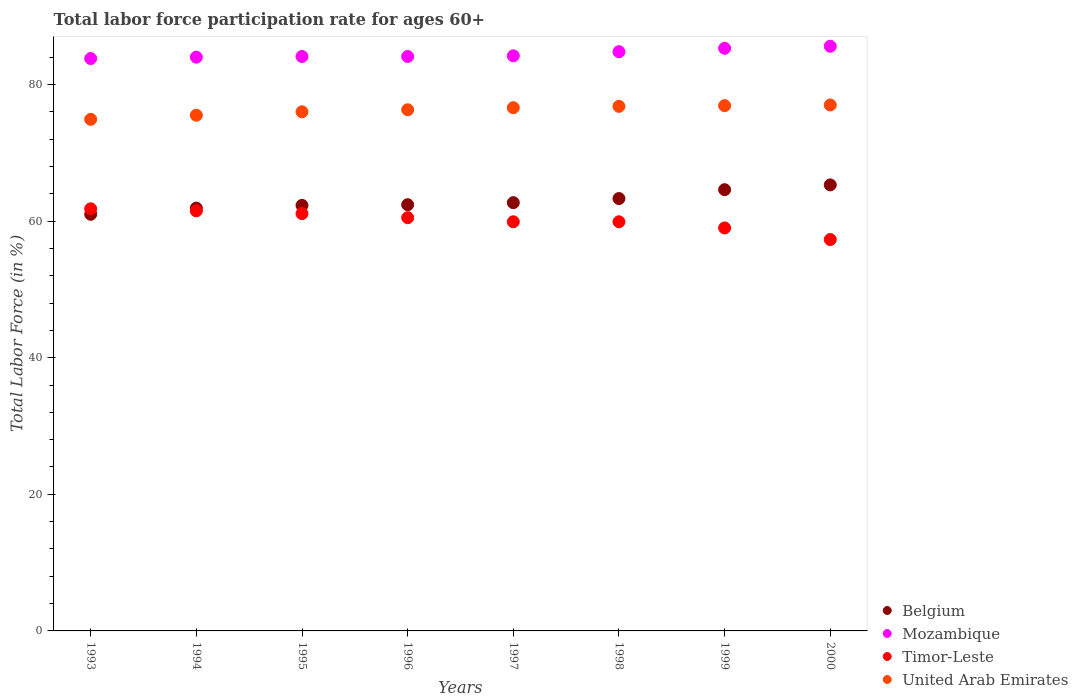Is the number of dotlines equal to the number of legend labels?
Ensure brevity in your answer.  Yes. What is the labor force participation rate in United Arab Emirates in 1996?
Make the answer very short. 76.3. Across all years, what is the maximum labor force participation rate in United Arab Emirates?
Provide a succinct answer. 77. Across all years, what is the minimum labor force participation rate in Mozambique?
Your answer should be very brief. 83.8. In which year was the labor force participation rate in Timor-Leste maximum?
Your response must be concise. 1993. In which year was the labor force participation rate in Mozambique minimum?
Keep it short and to the point. 1993. What is the total labor force participation rate in United Arab Emirates in the graph?
Provide a short and direct response. 610. What is the difference between the labor force participation rate in Timor-Leste in 1993 and that in 1994?
Ensure brevity in your answer.  0.3. What is the difference between the labor force participation rate in Belgium in 1998 and the labor force participation rate in Timor-Leste in 1996?
Offer a very short reply. 2.8. What is the average labor force participation rate in United Arab Emirates per year?
Offer a terse response. 76.25. In the year 2000, what is the difference between the labor force participation rate in Timor-Leste and labor force participation rate in United Arab Emirates?
Offer a terse response. -19.7. In how many years, is the labor force participation rate in Timor-Leste greater than 40 %?
Your response must be concise. 8. What is the ratio of the labor force participation rate in United Arab Emirates in 1993 to that in 1999?
Ensure brevity in your answer.  0.97. Is the labor force participation rate in Belgium in 1997 less than that in 1998?
Keep it short and to the point. Yes. What is the difference between the highest and the second highest labor force participation rate in Timor-Leste?
Keep it short and to the point. 0.3. What is the difference between the highest and the lowest labor force participation rate in Belgium?
Make the answer very short. 4.3. Is the sum of the labor force participation rate in Belgium in 1996 and 2000 greater than the maximum labor force participation rate in Timor-Leste across all years?
Offer a terse response. Yes. Is it the case that in every year, the sum of the labor force participation rate in Timor-Leste and labor force participation rate in Belgium  is greater than the sum of labor force participation rate in Mozambique and labor force participation rate in United Arab Emirates?
Give a very brief answer. No. Is it the case that in every year, the sum of the labor force participation rate in Mozambique and labor force participation rate in Belgium  is greater than the labor force participation rate in United Arab Emirates?
Make the answer very short. Yes. How many dotlines are there?
Your answer should be very brief. 4. How many years are there in the graph?
Provide a short and direct response. 8. Does the graph contain any zero values?
Keep it short and to the point. No. What is the title of the graph?
Make the answer very short. Total labor force participation rate for ages 60+. Does "World" appear as one of the legend labels in the graph?
Your answer should be very brief. No. What is the Total Labor Force (in %) in Belgium in 1993?
Offer a terse response. 61. What is the Total Labor Force (in %) of Mozambique in 1993?
Your answer should be very brief. 83.8. What is the Total Labor Force (in %) in Timor-Leste in 1993?
Provide a succinct answer. 61.8. What is the Total Labor Force (in %) of United Arab Emirates in 1993?
Your response must be concise. 74.9. What is the Total Labor Force (in %) in Belgium in 1994?
Provide a succinct answer. 61.9. What is the Total Labor Force (in %) of Mozambique in 1994?
Ensure brevity in your answer.  84. What is the Total Labor Force (in %) in Timor-Leste in 1994?
Provide a succinct answer. 61.5. What is the Total Labor Force (in %) in United Arab Emirates in 1994?
Your response must be concise. 75.5. What is the Total Labor Force (in %) in Belgium in 1995?
Make the answer very short. 62.3. What is the Total Labor Force (in %) of Mozambique in 1995?
Your answer should be very brief. 84.1. What is the Total Labor Force (in %) in Timor-Leste in 1995?
Your response must be concise. 61.1. What is the Total Labor Force (in %) of United Arab Emirates in 1995?
Your answer should be very brief. 76. What is the Total Labor Force (in %) of Belgium in 1996?
Provide a succinct answer. 62.4. What is the Total Labor Force (in %) in Mozambique in 1996?
Give a very brief answer. 84.1. What is the Total Labor Force (in %) in Timor-Leste in 1996?
Your answer should be compact. 60.5. What is the Total Labor Force (in %) in United Arab Emirates in 1996?
Keep it short and to the point. 76.3. What is the Total Labor Force (in %) of Belgium in 1997?
Give a very brief answer. 62.7. What is the Total Labor Force (in %) in Mozambique in 1997?
Offer a very short reply. 84.2. What is the Total Labor Force (in %) of Timor-Leste in 1997?
Provide a short and direct response. 59.9. What is the Total Labor Force (in %) in United Arab Emirates in 1997?
Keep it short and to the point. 76.6. What is the Total Labor Force (in %) of Belgium in 1998?
Keep it short and to the point. 63.3. What is the Total Labor Force (in %) of Mozambique in 1998?
Ensure brevity in your answer.  84.8. What is the Total Labor Force (in %) in Timor-Leste in 1998?
Offer a terse response. 59.9. What is the Total Labor Force (in %) in United Arab Emirates in 1998?
Ensure brevity in your answer.  76.8. What is the Total Labor Force (in %) of Belgium in 1999?
Provide a succinct answer. 64.6. What is the Total Labor Force (in %) of Mozambique in 1999?
Provide a succinct answer. 85.3. What is the Total Labor Force (in %) of United Arab Emirates in 1999?
Your answer should be compact. 76.9. What is the Total Labor Force (in %) in Belgium in 2000?
Your answer should be very brief. 65.3. What is the Total Labor Force (in %) of Mozambique in 2000?
Provide a short and direct response. 85.6. What is the Total Labor Force (in %) of Timor-Leste in 2000?
Ensure brevity in your answer.  57.3. Across all years, what is the maximum Total Labor Force (in %) of Belgium?
Provide a short and direct response. 65.3. Across all years, what is the maximum Total Labor Force (in %) in Mozambique?
Provide a succinct answer. 85.6. Across all years, what is the maximum Total Labor Force (in %) of Timor-Leste?
Provide a succinct answer. 61.8. Across all years, what is the maximum Total Labor Force (in %) of United Arab Emirates?
Provide a short and direct response. 77. Across all years, what is the minimum Total Labor Force (in %) of Mozambique?
Keep it short and to the point. 83.8. Across all years, what is the minimum Total Labor Force (in %) of Timor-Leste?
Your answer should be very brief. 57.3. Across all years, what is the minimum Total Labor Force (in %) in United Arab Emirates?
Give a very brief answer. 74.9. What is the total Total Labor Force (in %) of Belgium in the graph?
Your answer should be very brief. 503.5. What is the total Total Labor Force (in %) in Mozambique in the graph?
Make the answer very short. 675.9. What is the total Total Labor Force (in %) of Timor-Leste in the graph?
Offer a very short reply. 481. What is the total Total Labor Force (in %) in United Arab Emirates in the graph?
Ensure brevity in your answer.  610. What is the difference between the Total Labor Force (in %) of Belgium in 1993 and that in 1994?
Provide a succinct answer. -0.9. What is the difference between the Total Labor Force (in %) in Mozambique in 1993 and that in 1994?
Provide a succinct answer. -0.2. What is the difference between the Total Labor Force (in %) in Timor-Leste in 1993 and that in 1994?
Your answer should be very brief. 0.3. What is the difference between the Total Labor Force (in %) of United Arab Emirates in 1993 and that in 1994?
Your answer should be very brief. -0.6. What is the difference between the Total Labor Force (in %) in Mozambique in 1993 and that in 1995?
Your response must be concise. -0.3. What is the difference between the Total Labor Force (in %) in Timor-Leste in 1993 and that in 1995?
Make the answer very short. 0.7. What is the difference between the Total Labor Force (in %) of United Arab Emirates in 1993 and that in 1995?
Your answer should be compact. -1.1. What is the difference between the Total Labor Force (in %) of Belgium in 1993 and that in 1996?
Give a very brief answer. -1.4. What is the difference between the Total Labor Force (in %) of Mozambique in 1993 and that in 1996?
Keep it short and to the point. -0.3. What is the difference between the Total Labor Force (in %) of Timor-Leste in 1993 and that in 1996?
Keep it short and to the point. 1.3. What is the difference between the Total Labor Force (in %) in Belgium in 1993 and that in 1997?
Keep it short and to the point. -1.7. What is the difference between the Total Labor Force (in %) in Belgium in 1993 and that in 1998?
Give a very brief answer. -2.3. What is the difference between the Total Labor Force (in %) in United Arab Emirates in 1993 and that in 1998?
Offer a very short reply. -1.9. What is the difference between the Total Labor Force (in %) in Mozambique in 1993 and that in 2000?
Provide a succinct answer. -1.8. What is the difference between the Total Labor Force (in %) of Timor-Leste in 1993 and that in 2000?
Make the answer very short. 4.5. What is the difference between the Total Labor Force (in %) of Timor-Leste in 1994 and that in 1995?
Provide a succinct answer. 0.4. What is the difference between the Total Labor Force (in %) of Timor-Leste in 1994 and that in 1996?
Ensure brevity in your answer.  1. What is the difference between the Total Labor Force (in %) in Belgium in 1994 and that in 1997?
Ensure brevity in your answer.  -0.8. What is the difference between the Total Labor Force (in %) in Timor-Leste in 1994 and that in 1997?
Keep it short and to the point. 1.6. What is the difference between the Total Labor Force (in %) in Mozambique in 1994 and that in 1998?
Offer a terse response. -0.8. What is the difference between the Total Labor Force (in %) in United Arab Emirates in 1994 and that in 1998?
Offer a very short reply. -1.3. What is the difference between the Total Labor Force (in %) in Belgium in 1994 and that in 1999?
Your response must be concise. -2.7. What is the difference between the Total Labor Force (in %) in Mozambique in 1994 and that in 1999?
Make the answer very short. -1.3. What is the difference between the Total Labor Force (in %) in Timor-Leste in 1994 and that in 1999?
Your response must be concise. 2.5. What is the difference between the Total Labor Force (in %) in United Arab Emirates in 1994 and that in 1999?
Provide a succinct answer. -1.4. What is the difference between the Total Labor Force (in %) of Belgium in 1994 and that in 2000?
Give a very brief answer. -3.4. What is the difference between the Total Labor Force (in %) of United Arab Emirates in 1994 and that in 2000?
Your answer should be compact. -1.5. What is the difference between the Total Labor Force (in %) in Belgium in 1995 and that in 1996?
Provide a short and direct response. -0.1. What is the difference between the Total Labor Force (in %) of Timor-Leste in 1995 and that in 1996?
Offer a very short reply. 0.6. What is the difference between the Total Labor Force (in %) of United Arab Emirates in 1995 and that in 1996?
Ensure brevity in your answer.  -0.3. What is the difference between the Total Labor Force (in %) of Timor-Leste in 1995 and that in 1997?
Ensure brevity in your answer.  1.2. What is the difference between the Total Labor Force (in %) of United Arab Emirates in 1995 and that in 1997?
Provide a succinct answer. -0.6. What is the difference between the Total Labor Force (in %) of United Arab Emirates in 1995 and that in 1998?
Provide a succinct answer. -0.8. What is the difference between the Total Labor Force (in %) in Belgium in 1995 and that in 1999?
Offer a very short reply. -2.3. What is the difference between the Total Labor Force (in %) in United Arab Emirates in 1996 and that in 1997?
Your answer should be compact. -0.3. What is the difference between the Total Labor Force (in %) of Belgium in 1996 and that in 1998?
Make the answer very short. -0.9. What is the difference between the Total Labor Force (in %) in Mozambique in 1996 and that in 1998?
Provide a succinct answer. -0.7. What is the difference between the Total Labor Force (in %) in Timor-Leste in 1996 and that in 1998?
Ensure brevity in your answer.  0.6. What is the difference between the Total Labor Force (in %) of Belgium in 1996 and that in 1999?
Make the answer very short. -2.2. What is the difference between the Total Labor Force (in %) of Mozambique in 1996 and that in 1999?
Provide a short and direct response. -1.2. What is the difference between the Total Labor Force (in %) in Timor-Leste in 1996 and that in 1999?
Ensure brevity in your answer.  1.5. What is the difference between the Total Labor Force (in %) of Mozambique in 1996 and that in 2000?
Provide a succinct answer. -1.5. What is the difference between the Total Labor Force (in %) in Timor-Leste in 1996 and that in 2000?
Make the answer very short. 3.2. What is the difference between the Total Labor Force (in %) in United Arab Emirates in 1996 and that in 2000?
Offer a very short reply. -0.7. What is the difference between the Total Labor Force (in %) in Belgium in 1997 and that in 1998?
Provide a short and direct response. -0.6. What is the difference between the Total Labor Force (in %) of Timor-Leste in 1997 and that in 1998?
Your answer should be compact. 0. What is the difference between the Total Labor Force (in %) of United Arab Emirates in 1997 and that in 1998?
Your answer should be very brief. -0.2. What is the difference between the Total Labor Force (in %) of Belgium in 1997 and that in 1999?
Provide a succinct answer. -1.9. What is the difference between the Total Labor Force (in %) of Timor-Leste in 1997 and that in 1999?
Ensure brevity in your answer.  0.9. What is the difference between the Total Labor Force (in %) of United Arab Emirates in 1997 and that in 1999?
Give a very brief answer. -0.3. What is the difference between the Total Labor Force (in %) in Belgium in 1997 and that in 2000?
Provide a succinct answer. -2.6. What is the difference between the Total Labor Force (in %) in Mozambique in 1997 and that in 2000?
Offer a very short reply. -1.4. What is the difference between the Total Labor Force (in %) in Timor-Leste in 1997 and that in 2000?
Give a very brief answer. 2.6. What is the difference between the Total Labor Force (in %) of United Arab Emirates in 1998 and that in 1999?
Your response must be concise. -0.1. What is the difference between the Total Labor Force (in %) of Belgium in 1998 and that in 2000?
Provide a succinct answer. -2. What is the difference between the Total Labor Force (in %) of Mozambique in 1998 and that in 2000?
Ensure brevity in your answer.  -0.8. What is the difference between the Total Labor Force (in %) in Timor-Leste in 1998 and that in 2000?
Make the answer very short. 2.6. What is the difference between the Total Labor Force (in %) in Belgium in 1999 and that in 2000?
Your answer should be compact. -0.7. What is the difference between the Total Labor Force (in %) of Timor-Leste in 1999 and that in 2000?
Your answer should be compact. 1.7. What is the difference between the Total Labor Force (in %) of Belgium in 1993 and the Total Labor Force (in %) of Mozambique in 1994?
Make the answer very short. -23. What is the difference between the Total Labor Force (in %) of Mozambique in 1993 and the Total Labor Force (in %) of Timor-Leste in 1994?
Ensure brevity in your answer.  22.3. What is the difference between the Total Labor Force (in %) of Timor-Leste in 1993 and the Total Labor Force (in %) of United Arab Emirates in 1994?
Ensure brevity in your answer.  -13.7. What is the difference between the Total Labor Force (in %) of Belgium in 1993 and the Total Labor Force (in %) of Mozambique in 1995?
Provide a succinct answer. -23.1. What is the difference between the Total Labor Force (in %) of Belgium in 1993 and the Total Labor Force (in %) of United Arab Emirates in 1995?
Keep it short and to the point. -15. What is the difference between the Total Labor Force (in %) of Mozambique in 1993 and the Total Labor Force (in %) of Timor-Leste in 1995?
Your answer should be very brief. 22.7. What is the difference between the Total Labor Force (in %) of Belgium in 1993 and the Total Labor Force (in %) of Mozambique in 1996?
Offer a very short reply. -23.1. What is the difference between the Total Labor Force (in %) in Belgium in 1993 and the Total Labor Force (in %) in Timor-Leste in 1996?
Keep it short and to the point. 0.5. What is the difference between the Total Labor Force (in %) of Belgium in 1993 and the Total Labor Force (in %) of United Arab Emirates in 1996?
Offer a terse response. -15.3. What is the difference between the Total Labor Force (in %) in Mozambique in 1993 and the Total Labor Force (in %) in Timor-Leste in 1996?
Offer a very short reply. 23.3. What is the difference between the Total Labor Force (in %) of Mozambique in 1993 and the Total Labor Force (in %) of United Arab Emirates in 1996?
Keep it short and to the point. 7.5. What is the difference between the Total Labor Force (in %) in Belgium in 1993 and the Total Labor Force (in %) in Mozambique in 1997?
Make the answer very short. -23.2. What is the difference between the Total Labor Force (in %) of Belgium in 1993 and the Total Labor Force (in %) of Timor-Leste in 1997?
Provide a succinct answer. 1.1. What is the difference between the Total Labor Force (in %) of Belgium in 1993 and the Total Labor Force (in %) of United Arab Emirates in 1997?
Keep it short and to the point. -15.6. What is the difference between the Total Labor Force (in %) in Mozambique in 1993 and the Total Labor Force (in %) in Timor-Leste in 1997?
Provide a short and direct response. 23.9. What is the difference between the Total Labor Force (in %) of Timor-Leste in 1993 and the Total Labor Force (in %) of United Arab Emirates in 1997?
Your response must be concise. -14.8. What is the difference between the Total Labor Force (in %) in Belgium in 1993 and the Total Labor Force (in %) in Mozambique in 1998?
Offer a terse response. -23.8. What is the difference between the Total Labor Force (in %) in Belgium in 1993 and the Total Labor Force (in %) in Timor-Leste in 1998?
Your response must be concise. 1.1. What is the difference between the Total Labor Force (in %) in Belgium in 1993 and the Total Labor Force (in %) in United Arab Emirates in 1998?
Offer a very short reply. -15.8. What is the difference between the Total Labor Force (in %) of Mozambique in 1993 and the Total Labor Force (in %) of Timor-Leste in 1998?
Your answer should be compact. 23.9. What is the difference between the Total Labor Force (in %) in Belgium in 1993 and the Total Labor Force (in %) in Mozambique in 1999?
Your answer should be very brief. -24.3. What is the difference between the Total Labor Force (in %) in Belgium in 1993 and the Total Labor Force (in %) in United Arab Emirates in 1999?
Keep it short and to the point. -15.9. What is the difference between the Total Labor Force (in %) in Mozambique in 1993 and the Total Labor Force (in %) in Timor-Leste in 1999?
Ensure brevity in your answer.  24.8. What is the difference between the Total Labor Force (in %) of Mozambique in 1993 and the Total Labor Force (in %) of United Arab Emirates in 1999?
Provide a succinct answer. 6.9. What is the difference between the Total Labor Force (in %) in Timor-Leste in 1993 and the Total Labor Force (in %) in United Arab Emirates in 1999?
Your response must be concise. -15.1. What is the difference between the Total Labor Force (in %) of Belgium in 1993 and the Total Labor Force (in %) of Mozambique in 2000?
Provide a succinct answer. -24.6. What is the difference between the Total Labor Force (in %) of Mozambique in 1993 and the Total Labor Force (in %) of Timor-Leste in 2000?
Ensure brevity in your answer.  26.5. What is the difference between the Total Labor Force (in %) of Mozambique in 1993 and the Total Labor Force (in %) of United Arab Emirates in 2000?
Your answer should be very brief. 6.8. What is the difference between the Total Labor Force (in %) of Timor-Leste in 1993 and the Total Labor Force (in %) of United Arab Emirates in 2000?
Your answer should be very brief. -15.2. What is the difference between the Total Labor Force (in %) in Belgium in 1994 and the Total Labor Force (in %) in Mozambique in 1995?
Offer a terse response. -22.2. What is the difference between the Total Labor Force (in %) in Belgium in 1994 and the Total Labor Force (in %) in Timor-Leste in 1995?
Your response must be concise. 0.8. What is the difference between the Total Labor Force (in %) in Belgium in 1994 and the Total Labor Force (in %) in United Arab Emirates in 1995?
Ensure brevity in your answer.  -14.1. What is the difference between the Total Labor Force (in %) of Mozambique in 1994 and the Total Labor Force (in %) of Timor-Leste in 1995?
Provide a short and direct response. 22.9. What is the difference between the Total Labor Force (in %) in Timor-Leste in 1994 and the Total Labor Force (in %) in United Arab Emirates in 1995?
Offer a terse response. -14.5. What is the difference between the Total Labor Force (in %) in Belgium in 1994 and the Total Labor Force (in %) in Mozambique in 1996?
Your response must be concise. -22.2. What is the difference between the Total Labor Force (in %) in Belgium in 1994 and the Total Labor Force (in %) in Timor-Leste in 1996?
Make the answer very short. 1.4. What is the difference between the Total Labor Force (in %) of Belgium in 1994 and the Total Labor Force (in %) of United Arab Emirates in 1996?
Make the answer very short. -14.4. What is the difference between the Total Labor Force (in %) of Mozambique in 1994 and the Total Labor Force (in %) of Timor-Leste in 1996?
Offer a very short reply. 23.5. What is the difference between the Total Labor Force (in %) of Mozambique in 1994 and the Total Labor Force (in %) of United Arab Emirates in 1996?
Ensure brevity in your answer.  7.7. What is the difference between the Total Labor Force (in %) in Timor-Leste in 1994 and the Total Labor Force (in %) in United Arab Emirates in 1996?
Ensure brevity in your answer.  -14.8. What is the difference between the Total Labor Force (in %) of Belgium in 1994 and the Total Labor Force (in %) of Mozambique in 1997?
Keep it short and to the point. -22.3. What is the difference between the Total Labor Force (in %) in Belgium in 1994 and the Total Labor Force (in %) in Timor-Leste in 1997?
Your response must be concise. 2. What is the difference between the Total Labor Force (in %) in Belgium in 1994 and the Total Labor Force (in %) in United Arab Emirates in 1997?
Offer a very short reply. -14.7. What is the difference between the Total Labor Force (in %) in Mozambique in 1994 and the Total Labor Force (in %) in Timor-Leste in 1997?
Keep it short and to the point. 24.1. What is the difference between the Total Labor Force (in %) of Mozambique in 1994 and the Total Labor Force (in %) of United Arab Emirates in 1997?
Provide a succinct answer. 7.4. What is the difference between the Total Labor Force (in %) in Timor-Leste in 1994 and the Total Labor Force (in %) in United Arab Emirates in 1997?
Provide a succinct answer. -15.1. What is the difference between the Total Labor Force (in %) of Belgium in 1994 and the Total Labor Force (in %) of Mozambique in 1998?
Offer a very short reply. -22.9. What is the difference between the Total Labor Force (in %) of Belgium in 1994 and the Total Labor Force (in %) of Timor-Leste in 1998?
Make the answer very short. 2. What is the difference between the Total Labor Force (in %) in Belgium in 1994 and the Total Labor Force (in %) in United Arab Emirates in 1998?
Provide a short and direct response. -14.9. What is the difference between the Total Labor Force (in %) of Mozambique in 1994 and the Total Labor Force (in %) of Timor-Leste in 1998?
Provide a succinct answer. 24.1. What is the difference between the Total Labor Force (in %) in Mozambique in 1994 and the Total Labor Force (in %) in United Arab Emirates in 1998?
Your answer should be compact. 7.2. What is the difference between the Total Labor Force (in %) in Timor-Leste in 1994 and the Total Labor Force (in %) in United Arab Emirates in 1998?
Your answer should be compact. -15.3. What is the difference between the Total Labor Force (in %) of Belgium in 1994 and the Total Labor Force (in %) of Mozambique in 1999?
Provide a succinct answer. -23.4. What is the difference between the Total Labor Force (in %) in Belgium in 1994 and the Total Labor Force (in %) in United Arab Emirates in 1999?
Keep it short and to the point. -15. What is the difference between the Total Labor Force (in %) in Mozambique in 1994 and the Total Labor Force (in %) in United Arab Emirates in 1999?
Your answer should be very brief. 7.1. What is the difference between the Total Labor Force (in %) of Timor-Leste in 1994 and the Total Labor Force (in %) of United Arab Emirates in 1999?
Provide a succinct answer. -15.4. What is the difference between the Total Labor Force (in %) of Belgium in 1994 and the Total Labor Force (in %) of Mozambique in 2000?
Your response must be concise. -23.7. What is the difference between the Total Labor Force (in %) of Belgium in 1994 and the Total Labor Force (in %) of Timor-Leste in 2000?
Your answer should be compact. 4.6. What is the difference between the Total Labor Force (in %) in Belgium in 1994 and the Total Labor Force (in %) in United Arab Emirates in 2000?
Make the answer very short. -15.1. What is the difference between the Total Labor Force (in %) in Mozambique in 1994 and the Total Labor Force (in %) in Timor-Leste in 2000?
Make the answer very short. 26.7. What is the difference between the Total Labor Force (in %) in Mozambique in 1994 and the Total Labor Force (in %) in United Arab Emirates in 2000?
Provide a short and direct response. 7. What is the difference between the Total Labor Force (in %) in Timor-Leste in 1994 and the Total Labor Force (in %) in United Arab Emirates in 2000?
Provide a short and direct response. -15.5. What is the difference between the Total Labor Force (in %) in Belgium in 1995 and the Total Labor Force (in %) in Mozambique in 1996?
Ensure brevity in your answer.  -21.8. What is the difference between the Total Labor Force (in %) of Belgium in 1995 and the Total Labor Force (in %) of United Arab Emirates in 1996?
Your answer should be very brief. -14. What is the difference between the Total Labor Force (in %) in Mozambique in 1995 and the Total Labor Force (in %) in Timor-Leste in 1996?
Make the answer very short. 23.6. What is the difference between the Total Labor Force (in %) of Mozambique in 1995 and the Total Labor Force (in %) of United Arab Emirates in 1996?
Provide a succinct answer. 7.8. What is the difference between the Total Labor Force (in %) of Timor-Leste in 1995 and the Total Labor Force (in %) of United Arab Emirates in 1996?
Ensure brevity in your answer.  -15.2. What is the difference between the Total Labor Force (in %) in Belgium in 1995 and the Total Labor Force (in %) in Mozambique in 1997?
Your response must be concise. -21.9. What is the difference between the Total Labor Force (in %) in Belgium in 1995 and the Total Labor Force (in %) in Timor-Leste in 1997?
Offer a very short reply. 2.4. What is the difference between the Total Labor Force (in %) in Belgium in 1995 and the Total Labor Force (in %) in United Arab Emirates in 1997?
Your response must be concise. -14.3. What is the difference between the Total Labor Force (in %) in Mozambique in 1995 and the Total Labor Force (in %) in Timor-Leste in 1997?
Your answer should be compact. 24.2. What is the difference between the Total Labor Force (in %) in Timor-Leste in 1995 and the Total Labor Force (in %) in United Arab Emirates in 1997?
Your answer should be very brief. -15.5. What is the difference between the Total Labor Force (in %) in Belgium in 1995 and the Total Labor Force (in %) in Mozambique in 1998?
Keep it short and to the point. -22.5. What is the difference between the Total Labor Force (in %) in Belgium in 1995 and the Total Labor Force (in %) in Timor-Leste in 1998?
Ensure brevity in your answer.  2.4. What is the difference between the Total Labor Force (in %) in Mozambique in 1995 and the Total Labor Force (in %) in Timor-Leste in 1998?
Offer a terse response. 24.2. What is the difference between the Total Labor Force (in %) of Timor-Leste in 1995 and the Total Labor Force (in %) of United Arab Emirates in 1998?
Your answer should be compact. -15.7. What is the difference between the Total Labor Force (in %) of Belgium in 1995 and the Total Labor Force (in %) of Mozambique in 1999?
Offer a terse response. -23. What is the difference between the Total Labor Force (in %) of Belgium in 1995 and the Total Labor Force (in %) of United Arab Emirates in 1999?
Your answer should be very brief. -14.6. What is the difference between the Total Labor Force (in %) in Mozambique in 1995 and the Total Labor Force (in %) in Timor-Leste in 1999?
Keep it short and to the point. 25.1. What is the difference between the Total Labor Force (in %) in Mozambique in 1995 and the Total Labor Force (in %) in United Arab Emirates in 1999?
Your answer should be very brief. 7.2. What is the difference between the Total Labor Force (in %) in Timor-Leste in 1995 and the Total Labor Force (in %) in United Arab Emirates in 1999?
Ensure brevity in your answer.  -15.8. What is the difference between the Total Labor Force (in %) in Belgium in 1995 and the Total Labor Force (in %) in Mozambique in 2000?
Your response must be concise. -23.3. What is the difference between the Total Labor Force (in %) in Belgium in 1995 and the Total Labor Force (in %) in United Arab Emirates in 2000?
Provide a short and direct response. -14.7. What is the difference between the Total Labor Force (in %) in Mozambique in 1995 and the Total Labor Force (in %) in Timor-Leste in 2000?
Make the answer very short. 26.8. What is the difference between the Total Labor Force (in %) of Mozambique in 1995 and the Total Labor Force (in %) of United Arab Emirates in 2000?
Provide a succinct answer. 7.1. What is the difference between the Total Labor Force (in %) of Timor-Leste in 1995 and the Total Labor Force (in %) of United Arab Emirates in 2000?
Make the answer very short. -15.9. What is the difference between the Total Labor Force (in %) of Belgium in 1996 and the Total Labor Force (in %) of Mozambique in 1997?
Provide a succinct answer. -21.8. What is the difference between the Total Labor Force (in %) in Belgium in 1996 and the Total Labor Force (in %) in Timor-Leste in 1997?
Provide a succinct answer. 2.5. What is the difference between the Total Labor Force (in %) in Mozambique in 1996 and the Total Labor Force (in %) in Timor-Leste in 1997?
Make the answer very short. 24.2. What is the difference between the Total Labor Force (in %) of Timor-Leste in 1996 and the Total Labor Force (in %) of United Arab Emirates in 1997?
Offer a terse response. -16.1. What is the difference between the Total Labor Force (in %) of Belgium in 1996 and the Total Labor Force (in %) of Mozambique in 1998?
Offer a terse response. -22.4. What is the difference between the Total Labor Force (in %) in Belgium in 1996 and the Total Labor Force (in %) in Timor-Leste in 1998?
Ensure brevity in your answer.  2.5. What is the difference between the Total Labor Force (in %) of Belgium in 1996 and the Total Labor Force (in %) of United Arab Emirates in 1998?
Keep it short and to the point. -14.4. What is the difference between the Total Labor Force (in %) of Mozambique in 1996 and the Total Labor Force (in %) of Timor-Leste in 1998?
Offer a very short reply. 24.2. What is the difference between the Total Labor Force (in %) of Mozambique in 1996 and the Total Labor Force (in %) of United Arab Emirates in 1998?
Offer a terse response. 7.3. What is the difference between the Total Labor Force (in %) of Timor-Leste in 1996 and the Total Labor Force (in %) of United Arab Emirates in 1998?
Give a very brief answer. -16.3. What is the difference between the Total Labor Force (in %) of Belgium in 1996 and the Total Labor Force (in %) of Mozambique in 1999?
Make the answer very short. -22.9. What is the difference between the Total Labor Force (in %) of Belgium in 1996 and the Total Labor Force (in %) of Timor-Leste in 1999?
Your answer should be very brief. 3.4. What is the difference between the Total Labor Force (in %) of Mozambique in 1996 and the Total Labor Force (in %) of Timor-Leste in 1999?
Keep it short and to the point. 25.1. What is the difference between the Total Labor Force (in %) of Mozambique in 1996 and the Total Labor Force (in %) of United Arab Emirates in 1999?
Your response must be concise. 7.2. What is the difference between the Total Labor Force (in %) in Timor-Leste in 1996 and the Total Labor Force (in %) in United Arab Emirates in 1999?
Your answer should be compact. -16.4. What is the difference between the Total Labor Force (in %) in Belgium in 1996 and the Total Labor Force (in %) in Mozambique in 2000?
Your response must be concise. -23.2. What is the difference between the Total Labor Force (in %) in Belgium in 1996 and the Total Labor Force (in %) in United Arab Emirates in 2000?
Your response must be concise. -14.6. What is the difference between the Total Labor Force (in %) of Mozambique in 1996 and the Total Labor Force (in %) of Timor-Leste in 2000?
Your response must be concise. 26.8. What is the difference between the Total Labor Force (in %) of Timor-Leste in 1996 and the Total Labor Force (in %) of United Arab Emirates in 2000?
Your answer should be very brief. -16.5. What is the difference between the Total Labor Force (in %) in Belgium in 1997 and the Total Labor Force (in %) in Mozambique in 1998?
Offer a terse response. -22.1. What is the difference between the Total Labor Force (in %) of Belgium in 1997 and the Total Labor Force (in %) of United Arab Emirates in 1998?
Make the answer very short. -14.1. What is the difference between the Total Labor Force (in %) in Mozambique in 1997 and the Total Labor Force (in %) in Timor-Leste in 1998?
Your response must be concise. 24.3. What is the difference between the Total Labor Force (in %) of Mozambique in 1997 and the Total Labor Force (in %) of United Arab Emirates in 1998?
Provide a succinct answer. 7.4. What is the difference between the Total Labor Force (in %) in Timor-Leste in 1997 and the Total Labor Force (in %) in United Arab Emirates in 1998?
Ensure brevity in your answer.  -16.9. What is the difference between the Total Labor Force (in %) of Belgium in 1997 and the Total Labor Force (in %) of Mozambique in 1999?
Offer a terse response. -22.6. What is the difference between the Total Labor Force (in %) in Belgium in 1997 and the Total Labor Force (in %) in Timor-Leste in 1999?
Your answer should be compact. 3.7. What is the difference between the Total Labor Force (in %) of Mozambique in 1997 and the Total Labor Force (in %) of Timor-Leste in 1999?
Make the answer very short. 25.2. What is the difference between the Total Labor Force (in %) of Timor-Leste in 1997 and the Total Labor Force (in %) of United Arab Emirates in 1999?
Provide a succinct answer. -17. What is the difference between the Total Labor Force (in %) of Belgium in 1997 and the Total Labor Force (in %) of Mozambique in 2000?
Make the answer very short. -22.9. What is the difference between the Total Labor Force (in %) of Belgium in 1997 and the Total Labor Force (in %) of United Arab Emirates in 2000?
Your answer should be compact. -14.3. What is the difference between the Total Labor Force (in %) in Mozambique in 1997 and the Total Labor Force (in %) in Timor-Leste in 2000?
Your response must be concise. 26.9. What is the difference between the Total Labor Force (in %) of Mozambique in 1997 and the Total Labor Force (in %) of United Arab Emirates in 2000?
Your response must be concise. 7.2. What is the difference between the Total Labor Force (in %) of Timor-Leste in 1997 and the Total Labor Force (in %) of United Arab Emirates in 2000?
Offer a terse response. -17.1. What is the difference between the Total Labor Force (in %) in Belgium in 1998 and the Total Labor Force (in %) in United Arab Emirates in 1999?
Offer a terse response. -13.6. What is the difference between the Total Labor Force (in %) of Mozambique in 1998 and the Total Labor Force (in %) of Timor-Leste in 1999?
Keep it short and to the point. 25.8. What is the difference between the Total Labor Force (in %) of Timor-Leste in 1998 and the Total Labor Force (in %) of United Arab Emirates in 1999?
Your response must be concise. -17. What is the difference between the Total Labor Force (in %) of Belgium in 1998 and the Total Labor Force (in %) of Mozambique in 2000?
Your response must be concise. -22.3. What is the difference between the Total Labor Force (in %) of Belgium in 1998 and the Total Labor Force (in %) of Timor-Leste in 2000?
Provide a short and direct response. 6. What is the difference between the Total Labor Force (in %) of Belgium in 1998 and the Total Labor Force (in %) of United Arab Emirates in 2000?
Give a very brief answer. -13.7. What is the difference between the Total Labor Force (in %) of Timor-Leste in 1998 and the Total Labor Force (in %) of United Arab Emirates in 2000?
Your answer should be compact. -17.1. What is the difference between the Total Labor Force (in %) of Belgium in 1999 and the Total Labor Force (in %) of Timor-Leste in 2000?
Provide a short and direct response. 7.3. What is the difference between the Total Labor Force (in %) in Belgium in 1999 and the Total Labor Force (in %) in United Arab Emirates in 2000?
Offer a terse response. -12.4. What is the difference between the Total Labor Force (in %) of Mozambique in 1999 and the Total Labor Force (in %) of Timor-Leste in 2000?
Your response must be concise. 28. What is the difference between the Total Labor Force (in %) of Mozambique in 1999 and the Total Labor Force (in %) of United Arab Emirates in 2000?
Make the answer very short. 8.3. What is the average Total Labor Force (in %) of Belgium per year?
Your response must be concise. 62.94. What is the average Total Labor Force (in %) of Mozambique per year?
Offer a very short reply. 84.49. What is the average Total Labor Force (in %) in Timor-Leste per year?
Ensure brevity in your answer.  60.12. What is the average Total Labor Force (in %) in United Arab Emirates per year?
Offer a very short reply. 76.25. In the year 1993, what is the difference between the Total Labor Force (in %) of Belgium and Total Labor Force (in %) of Mozambique?
Offer a terse response. -22.8. In the year 1993, what is the difference between the Total Labor Force (in %) in Belgium and Total Labor Force (in %) in Timor-Leste?
Offer a very short reply. -0.8. In the year 1993, what is the difference between the Total Labor Force (in %) in Belgium and Total Labor Force (in %) in United Arab Emirates?
Give a very brief answer. -13.9. In the year 1993, what is the difference between the Total Labor Force (in %) of Mozambique and Total Labor Force (in %) of Timor-Leste?
Your answer should be compact. 22. In the year 1993, what is the difference between the Total Labor Force (in %) of Mozambique and Total Labor Force (in %) of United Arab Emirates?
Offer a terse response. 8.9. In the year 1993, what is the difference between the Total Labor Force (in %) in Timor-Leste and Total Labor Force (in %) in United Arab Emirates?
Keep it short and to the point. -13.1. In the year 1994, what is the difference between the Total Labor Force (in %) of Belgium and Total Labor Force (in %) of Mozambique?
Offer a very short reply. -22.1. In the year 1994, what is the difference between the Total Labor Force (in %) of Belgium and Total Labor Force (in %) of Timor-Leste?
Provide a short and direct response. 0.4. In the year 1994, what is the difference between the Total Labor Force (in %) in Belgium and Total Labor Force (in %) in United Arab Emirates?
Offer a terse response. -13.6. In the year 1994, what is the difference between the Total Labor Force (in %) in Mozambique and Total Labor Force (in %) in United Arab Emirates?
Offer a very short reply. 8.5. In the year 1995, what is the difference between the Total Labor Force (in %) in Belgium and Total Labor Force (in %) in Mozambique?
Give a very brief answer. -21.8. In the year 1995, what is the difference between the Total Labor Force (in %) in Belgium and Total Labor Force (in %) in Timor-Leste?
Make the answer very short. 1.2. In the year 1995, what is the difference between the Total Labor Force (in %) of Belgium and Total Labor Force (in %) of United Arab Emirates?
Provide a succinct answer. -13.7. In the year 1995, what is the difference between the Total Labor Force (in %) of Mozambique and Total Labor Force (in %) of Timor-Leste?
Give a very brief answer. 23. In the year 1995, what is the difference between the Total Labor Force (in %) of Timor-Leste and Total Labor Force (in %) of United Arab Emirates?
Offer a terse response. -14.9. In the year 1996, what is the difference between the Total Labor Force (in %) of Belgium and Total Labor Force (in %) of Mozambique?
Keep it short and to the point. -21.7. In the year 1996, what is the difference between the Total Labor Force (in %) in Belgium and Total Labor Force (in %) in Timor-Leste?
Your response must be concise. 1.9. In the year 1996, what is the difference between the Total Labor Force (in %) of Mozambique and Total Labor Force (in %) of Timor-Leste?
Provide a succinct answer. 23.6. In the year 1996, what is the difference between the Total Labor Force (in %) of Mozambique and Total Labor Force (in %) of United Arab Emirates?
Ensure brevity in your answer.  7.8. In the year 1996, what is the difference between the Total Labor Force (in %) of Timor-Leste and Total Labor Force (in %) of United Arab Emirates?
Offer a very short reply. -15.8. In the year 1997, what is the difference between the Total Labor Force (in %) of Belgium and Total Labor Force (in %) of Mozambique?
Your answer should be very brief. -21.5. In the year 1997, what is the difference between the Total Labor Force (in %) of Belgium and Total Labor Force (in %) of United Arab Emirates?
Your response must be concise. -13.9. In the year 1997, what is the difference between the Total Labor Force (in %) of Mozambique and Total Labor Force (in %) of Timor-Leste?
Your response must be concise. 24.3. In the year 1997, what is the difference between the Total Labor Force (in %) in Timor-Leste and Total Labor Force (in %) in United Arab Emirates?
Keep it short and to the point. -16.7. In the year 1998, what is the difference between the Total Labor Force (in %) of Belgium and Total Labor Force (in %) of Mozambique?
Provide a short and direct response. -21.5. In the year 1998, what is the difference between the Total Labor Force (in %) in Belgium and Total Labor Force (in %) in United Arab Emirates?
Your answer should be very brief. -13.5. In the year 1998, what is the difference between the Total Labor Force (in %) in Mozambique and Total Labor Force (in %) in Timor-Leste?
Keep it short and to the point. 24.9. In the year 1998, what is the difference between the Total Labor Force (in %) in Mozambique and Total Labor Force (in %) in United Arab Emirates?
Offer a terse response. 8. In the year 1998, what is the difference between the Total Labor Force (in %) in Timor-Leste and Total Labor Force (in %) in United Arab Emirates?
Your answer should be very brief. -16.9. In the year 1999, what is the difference between the Total Labor Force (in %) in Belgium and Total Labor Force (in %) in Mozambique?
Provide a short and direct response. -20.7. In the year 1999, what is the difference between the Total Labor Force (in %) in Mozambique and Total Labor Force (in %) in Timor-Leste?
Provide a short and direct response. 26.3. In the year 1999, what is the difference between the Total Labor Force (in %) of Mozambique and Total Labor Force (in %) of United Arab Emirates?
Provide a short and direct response. 8.4. In the year 1999, what is the difference between the Total Labor Force (in %) of Timor-Leste and Total Labor Force (in %) of United Arab Emirates?
Your answer should be compact. -17.9. In the year 2000, what is the difference between the Total Labor Force (in %) in Belgium and Total Labor Force (in %) in Mozambique?
Your answer should be very brief. -20.3. In the year 2000, what is the difference between the Total Labor Force (in %) of Mozambique and Total Labor Force (in %) of Timor-Leste?
Provide a succinct answer. 28.3. In the year 2000, what is the difference between the Total Labor Force (in %) in Mozambique and Total Labor Force (in %) in United Arab Emirates?
Ensure brevity in your answer.  8.6. In the year 2000, what is the difference between the Total Labor Force (in %) in Timor-Leste and Total Labor Force (in %) in United Arab Emirates?
Give a very brief answer. -19.7. What is the ratio of the Total Labor Force (in %) in Belgium in 1993 to that in 1994?
Offer a terse response. 0.99. What is the ratio of the Total Labor Force (in %) in Mozambique in 1993 to that in 1994?
Offer a terse response. 1. What is the ratio of the Total Labor Force (in %) of Belgium in 1993 to that in 1995?
Your response must be concise. 0.98. What is the ratio of the Total Labor Force (in %) in Mozambique in 1993 to that in 1995?
Offer a very short reply. 1. What is the ratio of the Total Labor Force (in %) in Timor-Leste in 1993 to that in 1995?
Your answer should be compact. 1.01. What is the ratio of the Total Labor Force (in %) in United Arab Emirates in 1993 to that in 1995?
Offer a very short reply. 0.99. What is the ratio of the Total Labor Force (in %) in Belgium in 1993 to that in 1996?
Provide a short and direct response. 0.98. What is the ratio of the Total Labor Force (in %) in Mozambique in 1993 to that in 1996?
Make the answer very short. 1. What is the ratio of the Total Labor Force (in %) of Timor-Leste in 1993 to that in 1996?
Make the answer very short. 1.02. What is the ratio of the Total Labor Force (in %) of United Arab Emirates in 1993 to that in 1996?
Ensure brevity in your answer.  0.98. What is the ratio of the Total Labor Force (in %) in Belgium in 1993 to that in 1997?
Make the answer very short. 0.97. What is the ratio of the Total Labor Force (in %) in Timor-Leste in 1993 to that in 1997?
Offer a very short reply. 1.03. What is the ratio of the Total Labor Force (in %) in United Arab Emirates in 1993 to that in 1997?
Offer a terse response. 0.98. What is the ratio of the Total Labor Force (in %) in Belgium in 1993 to that in 1998?
Your answer should be very brief. 0.96. What is the ratio of the Total Labor Force (in %) of Mozambique in 1993 to that in 1998?
Your answer should be very brief. 0.99. What is the ratio of the Total Labor Force (in %) in Timor-Leste in 1993 to that in 1998?
Provide a short and direct response. 1.03. What is the ratio of the Total Labor Force (in %) of United Arab Emirates in 1993 to that in 1998?
Keep it short and to the point. 0.98. What is the ratio of the Total Labor Force (in %) in Belgium in 1993 to that in 1999?
Make the answer very short. 0.94. What is the ratio of the Total Labor Force (in %) of Mozambique in 1993 to that in 1999?
Keep it short and to the point. 0.98. What is the ratio of the Total Labor Force (in %) in Timor-Leste in 1993 to that in 1999?
Keep it short and to the point. 1.05. What is the ratio of the Total Labor Force (in %) in United Arab Emirates in 1993 to that in 1999?
Provide a succinct answer. 0.97. What is the ratio of the Total Labor Force (in %) in Belgium in 1993 to that in 2000?
Make the answer very short. 0.93. What is the ratio of the Total Labor Force (in %) in Mozambique in 1993 to that in 2000?
Make the answer very short. 0.98. What is the ratio of the Total Labor Force (in %) in Timor-Leste in 1993 to that in 2000?
Offer a terse response. 1.08. What is the ratio of the Total Labor Force (in %) in United Arab Emirates in 1993 to that in 2000?
Ensure brevity in your answer.  0.97. What is the ratio of the Total Labor Force (in %) of Belgium in 1994 to that in 1995?
Offer a very short reply. 0.99. What is the ratio of the Total Labor Force (in %) in United Arab Emirates in 1994 to that in 1995?
Ensure brevity in your answer.  0.99. What is the ratio of the Total Labor Force (in %) of Belgium in 1994 to that in 1996?
Provide a succinct answer. 0.99. What is the ratio of the Total Labor Force (in %) of Timor-Leste in 1994 to that in 1996?
Provide a short and direct response. 1.02. What is the ratio of the Total Labor Force (in %) of Belgium in 1994 to that in 1997?
Your answer should be compact. 0.99. What is the ratio of the Total Labor Force (in %) of Mozambique in 1994 to that in 1997?
Offer a very short reply. 1. What is the ratio of the Total Labor Force (in %) of Timor-Leste in 1994 to that in 1997?
Your answer should be very brief. 1.03. What is the ratio of the Total Labor Force (in %) of United Arab Emirates in 1994 to that in 1997?
Offer a very short reply. 0.99. What is the ratio of the Total Labor Force (in %) in Belgium in 1994 to that in 1998?
Provide a succinct answer. 0.98. What is the ratio of the Total Labor Force (in %) in Mozambique in 1994 to that in 1998?
Offer a terse response. 0.99. What is the ratio of the Total Labor Force (in %) of Timor-Leste in 1994 to that in 1998?
Your response must be concise. 1.03. What is the ratio of the Total Labor Force (in %) in United Arab Emirates in 1994 to that in 1998?
Your response must be concise. 0.98. What is the ratio of the Total Labor Force (in %) in Belgium in 1994 to that in 1999?
Keep it short and to the point. 0.96. What is the ratio of the Total Labor Force (in %) in Mozambique in 1994 to that in 1999?
Provide a succinct answer. 0.98. What is the ratio of the Total Labor Force (in %) of Timor-Leste in 1994 to that in 1999?
Ensure brevity in your answer.  1.04. What is the ratio of the Total Labor Force (in %) of United Arab Emirates in 1994 to that in 1999?
Keep it short and to the point. 0.98. What is the ratio of the Total Labor Force (in %) in Belgium in 1994 to that in 2000?
Your answer should be very brief. 0.95. What is the ratio of the Total Labor Force (in %) of Mozambique in 1994 to that in 2000?
Your answer should be compact. 0.98. What is the ratio of the Total Labor Force (in %) of Timor-Leste in 1994 to that in 2000?
Your response must be concise. 1.07. What is the ratio of the Total Labor Force (in %) of United Arab Emirates in 1994 to that in 2000?
Give a very brief answer. 0.98. What is the ratio of the Total Labor Force (in %) of Belgium in 1995 to that in 1996?
Your response must be concise. 1. What is the ratio of the Total Labor Force (in %) in Timor-Leste in 1995 to that in 1996?
Offer a terse response. 1.01. What is the ratio of the Total Labor Force (in %) in United Arab Emirates in 1995 to that in 1996?
Keep it short and to the point. 1. What is the ratio of the Total Labor Force (in %) of Belgium in 1995 to that in 1997?
Ensure brevity in your answer.  0.99. What is the ratio of the Total Labor Force (in %) in Timor-Leste in 1995 to that in 1997?
Offer a terse response. 1.02. What is the ratio of the Total Labor Force (in %) of United Arab Emirates in 1995 to that in 1997?
Give a very brief answer. 0.99. What is the ratio of the Total Labor Force (in %) of Belgium in 1995 to that in 1998?
Your response must be concise. 0.98. What is the ratio of the Total Labor Force (in %) of Belgium in 1995 to that in 1999?
Your answer should be very brief. 0.96. What is the ratio of the Total Labor Force (in %) in Mozambique in 1995 to that in 1999?
Offer a very short reply. 0.99. What is the ratio of the Total Labor Force (in %) of Timor-Leste in 1995 to that in 1999?
Make the answer very short. 1.04. What is the ratio of the Total Labor Force (in %) in United Arab Emirates in 1995 to that in 1999?
Ensure brevity in your answer.  0.99. What is the ratio of the Total Labor Force (in %) of Belgium in 1995 to that in 2000?
Offer a very short reply. 0.95. What is the ratio of the Total Labor Force (in %) in Mozambique in 1995 to that in 2000?
Your response must be concise. 0.98. What is the ratio of the Total Labor Force (in %) in Timor-Leste in 1995 to that in 2000?
Provide a succinct answer. 1.07. What is the ratio of the Total Labor Force (in %) in United Arab Emirates in 1995 to that in 2000?
Give a very brief answer. 0.99. What is the ratio of the Total Labor Force (in %) in Timor-Leste in 1996 to that in 1997?
Keep it short and to the point. 1.01. What is the ratio of the Total Labor Force (in %) in Belgium in 1996 to that in 1998?
Ensure brevity in your answer.  0.99. What is the ratio of the Total Labor Force (in %) of Timor-Leste in 1996 to that in 1998?
Provide a succinct answer. 1.01. What is the ratio of the Total Labor Force (in %) in Belgium in 1996 to that in 1999?
Your answer should be compact. 0.97. What is the ratio of the Total Labor Force (in %) in Mozambique in 1996 to that in 1999?
Your answer should be compact. 0.99. What is the ratio of the Total Labor Force (in %) of Timor-Leste in 1996 to that in 1999?
Keep it short and to the point. 1.03. What is the ratio of the Total Labor Force (in %) in United Arab Emirates in 1996 to that in 1999?
Provide a succinct answer. 0.99. What is the ratio of the Total Labor Force (in %) in Belgium in 1996 to that in 2000?
Give a very brief answer. 0.96. What is the ratio of the Total Labor Force (in %) in Mozambique in 1996 to that in 2000?
Offer a very short reply. 0.98. What is the ratio of the Total Labor Force (in %) of Timor-Leste in 1996 to that in 2000?
Offer a very short reply. 1.06. What is the ratio of the Total Labor Force (in %) in United Arab Emirates in 1996 to that in 2000?
Your response must be concise. 0.99. What is the ratio of the Total Labor Force (in %) in Belgium in 1997 to that in 1998?
Make the answer very short. 0.99. What is the ratio of the Total Labor Force (in %) in Mozambique in 1997 to that in 1998?
Give a very brief answer. 0.99. What is the ratio of the Total Labor Force (in %) of Timor-Leste in 1997 to that in 1998?
Keep it short and to the point. 1. What is the ratio of the Total Labor Force (in %) in Belgium in 1997 to that in 1999?
Make the answer very short. 0.97. What is the ratio of the Total Labor Force (in %) of Mozambique in 1997 to that in 1999?
Make the answer very short. 0.99. What is the ratio of the Total Labor Force (in %) in Timor-Leste in 1997 to that in 1999?
Make the answer very short. 1.02. What is the ratio of the Total Labor Force (in %) in Belgium in 1997 to that in 2000?
Ensure brevity in your answer.  0.96. What is the ratio of the Total Labor Force (in %) of Mozambique in 1997 to that in 2000?
Keep it short and to the point. 0.98. What is the ratio of the Total Labor Force (in %) in Timor-Leste in 1997 to that in 2000?
Provide a succinct answer. 1.05. What is the ratio of the Total Labor Force (in %) of Belgium in 1998 to that in 1999?
Offer a very short reply. 0.98. What is the ratio of the Total Labor Force (in %) in Timor-Leste in 1998 to that in 1999?
Provide a short and direct response. 1.02. What is the ratio of the Total Labor Force (in %) of United Arab Emirates in 1998 to that in 1999?
Keep it short and to the point. 1. What is the ratio of the Total Labor Force (in %) in Belgium in 1998 to that in 2000?
Give a very brief answer. 0.97. What is the ratio of the Total Labor Force (in %) in Mozambique in 1998 to that in 2000?
Your response must be concise. 0.99. What is the ratio of the Total Labor Force (in %) in Timor-Leste in 1998 to that in 2000?
Offer a terse response. 1.05. What is the ratio of the Total Labor Force (in %) in Belgium in 1999 to that in 2000?
Give a very brief answer. 0.99. What is the ratio of the Total Labor Force (in %) of Mozambique in 1999 to that in 2000?
Offer a very short reply. 1. What is the ratio of the Total Labor Force (in %) of Timor-Leste in 1999 to that in 2000?
Make the answer very short. 1.03. What is the ratio of the Total Labor Force (in %) in United Arab Emirates in 1999 to that in 2000?
Ensure brevity in your answer.  1. What is the difference between the highest and the second highest Total Labor Force (in %) of Belgium?
Provide a short and direct response. 0.7. What is the difference between the highest and the second highest Total Labor Force (in %) of Mozambique?
Your answer should be compact. 0.3. What is the difference between the highest and the second highest Total Labor Force (in %) in Timor-Leste?
Give a very brief answer. 0.3. What is the difference between the highest and the lowest Total Labor Force (in %) of Mozambique?
Keep it short and to the point. 1.8. What is the difference between the highest and the lowest Total Labor Force (in %) of Timor-Leste?
Offer a very short reply. 4.5. What is the difference between the highest and the lowest Total Labor Force (in %) of United Arab Emirates?
Offer a very short reply. 2.1. 